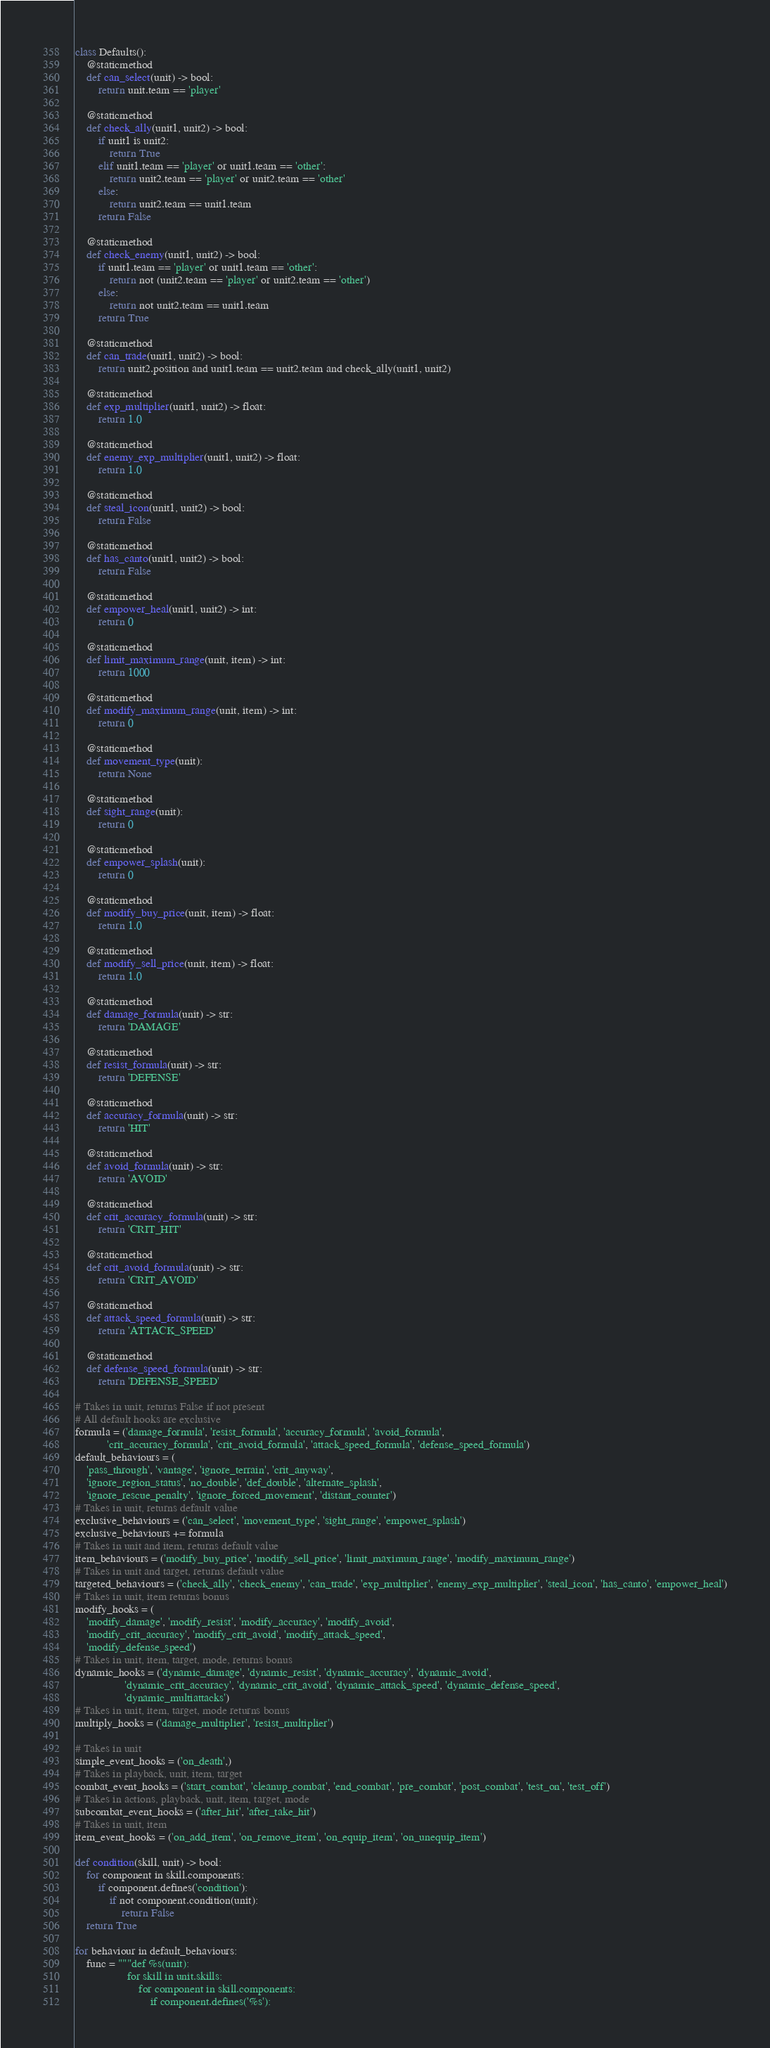Convert code to text. <code><loc_0><loc_0><loc_500><loc_500><_Python_>class Defaults():
    @staticmethod
    def can_select(unit) -> bool:
        return unit.team == 'player'

    @staticmethod
    def check_ally(unit1, unit2) -> bool:
        if unit1 is unit2:
            return True
        elif unit1.team == 'player' or unit1.team == 'other':
            return unit2.team == 'player' or unit2.team == 'other'
        else:
            return unit2.team == unit1.team
        return False

    @staticmethod
    def check_enemy(unit1, unit2) -> bool:
        if unit1.team == 'player' or unit1.team == 'other':
            return not (unit2.team == 'player' or unit2.team == 'other')
        else:
            return not unit2.team == unit1.team
        return True

    @staticmethod
    def can_trade(unit1, unit2) -> bool:
        return unit2.position and unit1.team == unit2.team and check_ally(unit1, unit2)

    @staticmethod
    def exp_multiplier(unit1, unit2) -> float:
        return 1.0

    @staticmethod
    def enemy_exp_multiplier(unit1, unit2) -> float:
        return 1.0

    @staticmethod
    def steal_icon(unit1, unit2) -> bool:
        return False

    @staticmethod
    def has_canto(unit1, unit2) -> bool:
        return False

    @staticmethod
    def empower_heal(unit1, unit2) -> int:
        return 0

    @staticmethod
    def limit_maximum_range(unit, item) -> int:
        return 1000

    @staticmethod
    def modify_maximum_range(unit, item) -> int:
        return 0

    @staticmethod
    def movement_type(unit):
        return None

    @staticmethod
    def sight_range(unit):
        return 0

    @staticmethod
    def empower_splash(unit):
        return 0

    @staticmethod
    def modify_buy_price(unit, item) -> float:
        return 1.0

    @staticmethod
    def modify_sell_price(unit, item) -> float:
        return 1.0

    @staticmethod
    def damage_formula(unit) -> str:
        return 'DAMAGE'

    @staticmethod
    def resist_formula(unit) -> str:
        return 'DEFENSE'

    @staticmethod
    def accuracy_formula(unit) -> str:
        return 'HIT'

    @staticmethod
    def avoid_formula(unit) -> str:
        return 'AVOID'

    @staticmethod
    def crit_accuracy_formula(unit) -> str:
        return 'CRIT_HIT'

    @staticmethod
    def crit_avoid_formula(unit) -> str:
        return 'CRIT_AVOID'

    @staticmethod
    def attack_speed_formula(unit) -> str:
        return 'ATTACK_SPEED'

    @staticmethod
    def defense_speed_formula(unit) -> str:
        return 'DEFENSE_SPEED'

# Takes in unit, returns False if not present
# All default hooks are exclusive
formula = ('damage_formula', 'resist_formula', 'accuracy_formula', 'avoid_formula', 
           'crit_accuracy_formula', 'crit_avoid_formula', 'attack_speed_formula', 'defense_speed_formula')
default_behaviours = (
    'pass_through', 'vantage', 'ignore_terrain', 'crit_anyway',
    'ignore_region_status', 'no_double', 'def_double', 'alternate_splash',
    'ignore_rescue_penalty', 'ignore_forced_movement', 'distant_counter')
# Takes in unit, returns default value
exclusive_behaviours = ('can_select', 'movement_type', 'sight_range', 'empower_splash')
exclusive_behaviours += formula
# Takes in unit and item, returns default value
item_behaviours = ('modify_buy_price', 'modify_sell_price', 'limit_maximum_range', 'modify_maximum_range')
# Takes in unit and target, returns default value
targeted_behaviours = ('check_ally', 'check_enemy', 'can_trade', 'exp_multiplier', 'enemy_exp_multiplier', 'steal_icon', 'has_canto', 'empower_heal')
# Takes in unit, item returns bonus
modify_hooks = (
    'modify_damage', 'modify_resist', 'modify_accuracy', 'modify_avoid', 
    'modify_crit_accuracy', 'modify_crit_avoid', 'modify_attack_speed', 
    'modify_defense_speed')
# Takes in unit, item, target, mode, returns bonus
dynamic_hooks = ('dynamic_damage', 'dynamic_resist', 'dynamic_accuracy', 'dynamic_avoid', 
                 'dynamic_crit_accuracy', 'dynamic_crit_avoid', 'dynamic_attack_speed', 'dynamic_defense_speed',
                 'dynamic_multiattacks')
# Takes in unit, item, target, mode returns bonus
multiply_hooks = ('damage_multiplier', 'resist_multiplier')

# Takes in unit
simple_event_hooks = ('on_death',)
# Takes in playback, unit, item, target
combat_event_hooks = ('start_combat', 'cleanup_combat', 'end_combat', 'pre_combat', 'post_combat', 'test_on', 'test_off')
# Takes in actions, playback, unit, item, target, mode
subcombat_event_hooks = ('after_hit', 'after_take_hit')
# Takes in unit, item
item_event_hooks = ('on_add_item', 'on_remove_item', 'on_equip_item', 'on_unequip_item')

def condition(skill, unit) -> bool:
    for component in skill.components:
        if component.defines('condition'):
            if not component.condition(unit):
                return False
    return True

for behaviour in default_behaviours:
    func = """def %s(unit):
                  for skill in unit.skills:
                      for component in skill.components:
                          if component.defines('%s'):</code> 